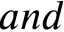<formula> <loc_0><loc_0><loc_500><loc_500>\ a n d</formula> 